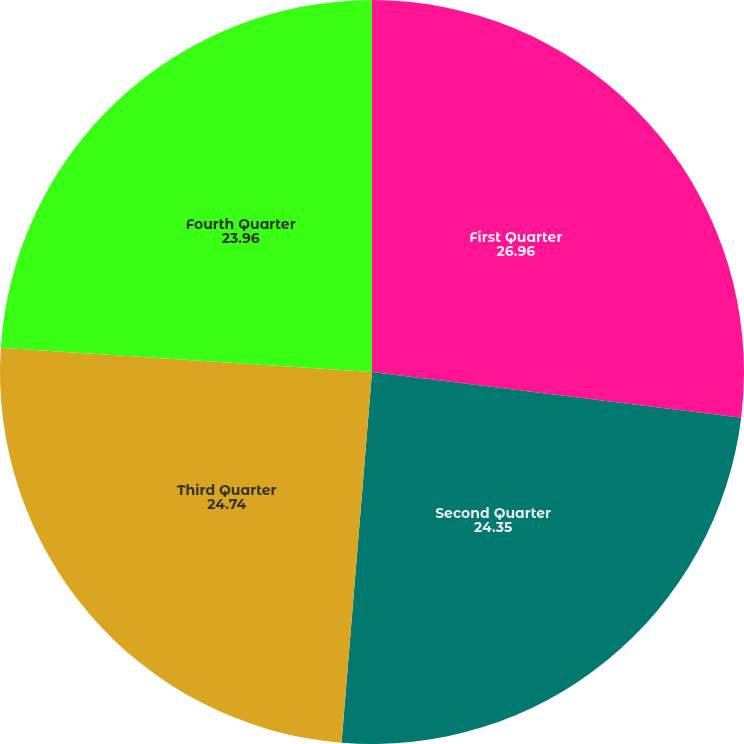Convert chart to OTSL. <chart><loc_0><loc_0><loc_500><loc_500><pie_chart><fcel>First Quarter<fcel>Second Quarter<fcel>Third Quarter<fcel>Fourth Quarter<nl><fcel>26.96%<fcel>24.35%<fcel>24.74%<fcel>23.96%<nl></chart> 